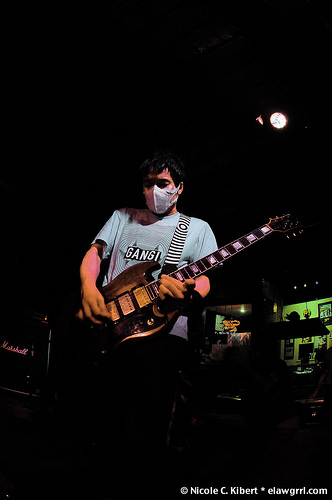<image>
Can you confirm if the guitar is on the wall? No. The guitar is not positioned on the wall. They may be near each other, but the guitar is not supported by or resting on top of the wall. Is the man on the guitar? No. The man is not positioned on the guitar. They may be near each other, but the man is not supported by or resting on top of the guitar. Is there a mask above the guitar? Yes. The mask is positioned above the guitar in the vertical space, higher up in the scene. 